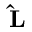<formula> <loc_0><loc_0><loc_500><loc_500>\hat { L }</formula> 